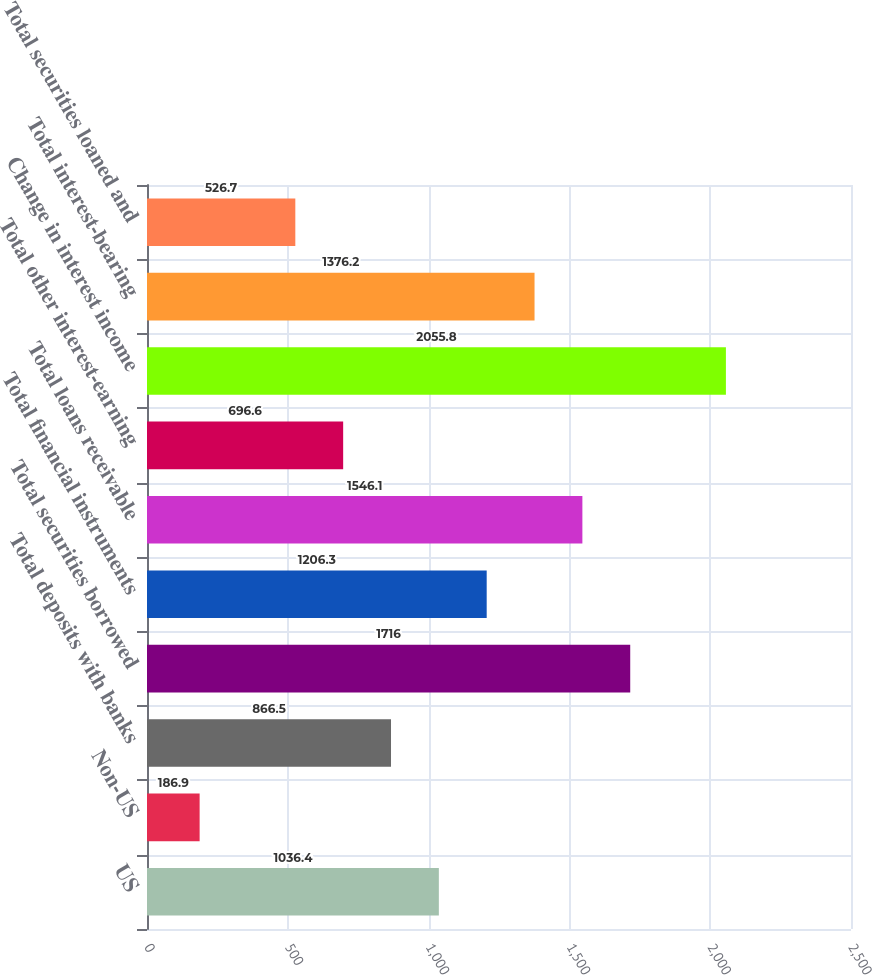<chart> <loc_0><loc_0><loc_500><loc_500><bar_chart><fcel>US<fcel>Non-US<fcel>Total deposits with banks<fcel>Total securities borrowed<fcel>Total financial instruments<fcel>Total loans receivable<fcel>Total other interest-earning<fcel>Change in interest income<fcel>Total interest-bearing<fcel>Total securities loaned and<nl><fcel>1036.4<fcel>186.9<fcel>866.5<fcel>1716<fcel>1206.3<fcel>1546.1<fcel>696.6<fcel>2055.8<fcel>1376.2<fcel>526.7<nl></chart> 